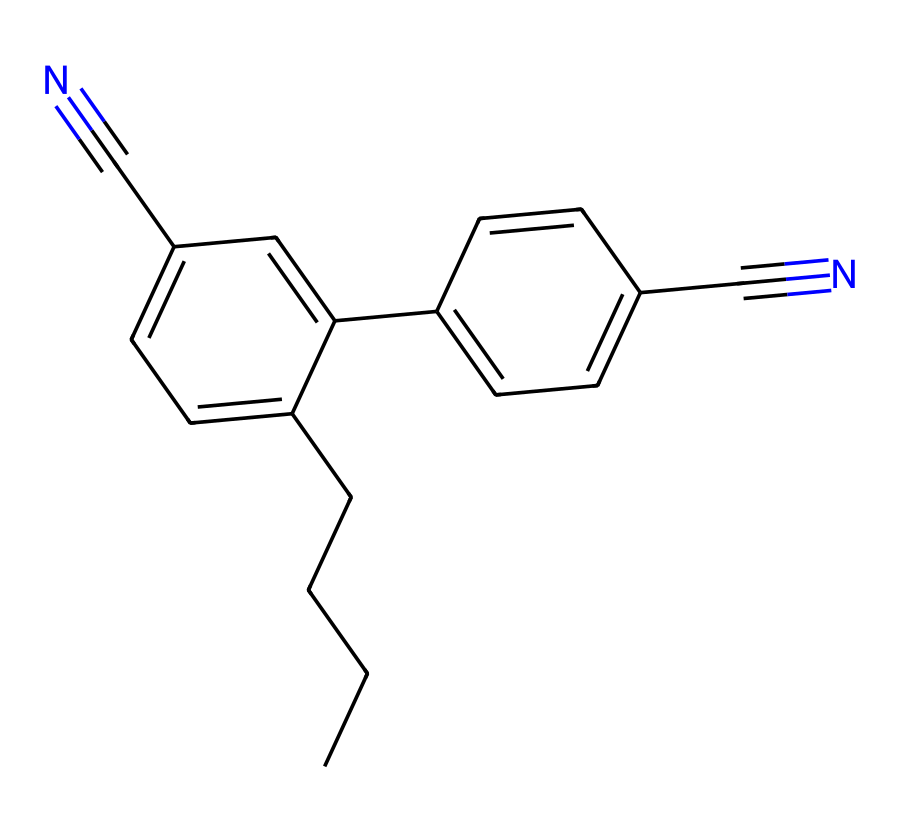What is the total number of carbon atoms in this chemical? By analyzing the SMILES representation, we can count the number of 'C' which represents carbon atoms. In this case, there are a total of 15 carbon atoms present in the structure.
Answer: 15 How many nitrogen atoms are present in this chemical? In the given SMILES representation, we find two occurrences of 'N', indicating the presence of two nitrogen atoms attached to the carbon framework.
Answer: 2 What functional groups are present in this chemical? The chemical structure contains cyano groups, indicated by the presence of the 'C#N' notation, which signifies the attached cyanide (nitrile) groups.
Answer: cyano groups What type of bonding is mainly present in this chemical? The presence of double bonds, as observed in the structure, indicates that there are multiple instances of carbon-carbon double bonds (C=C). This shows that the primary bonding type here is covalent.
Answer: covalent Which molecular structure contributes to the liquid crystal properties? The elongated and rigid aromatic rings in the structure contribute to the liquid crystalline properties, allowing for the alignment of the molecules under the influence of an electric field.
Answer: aromatic rings 